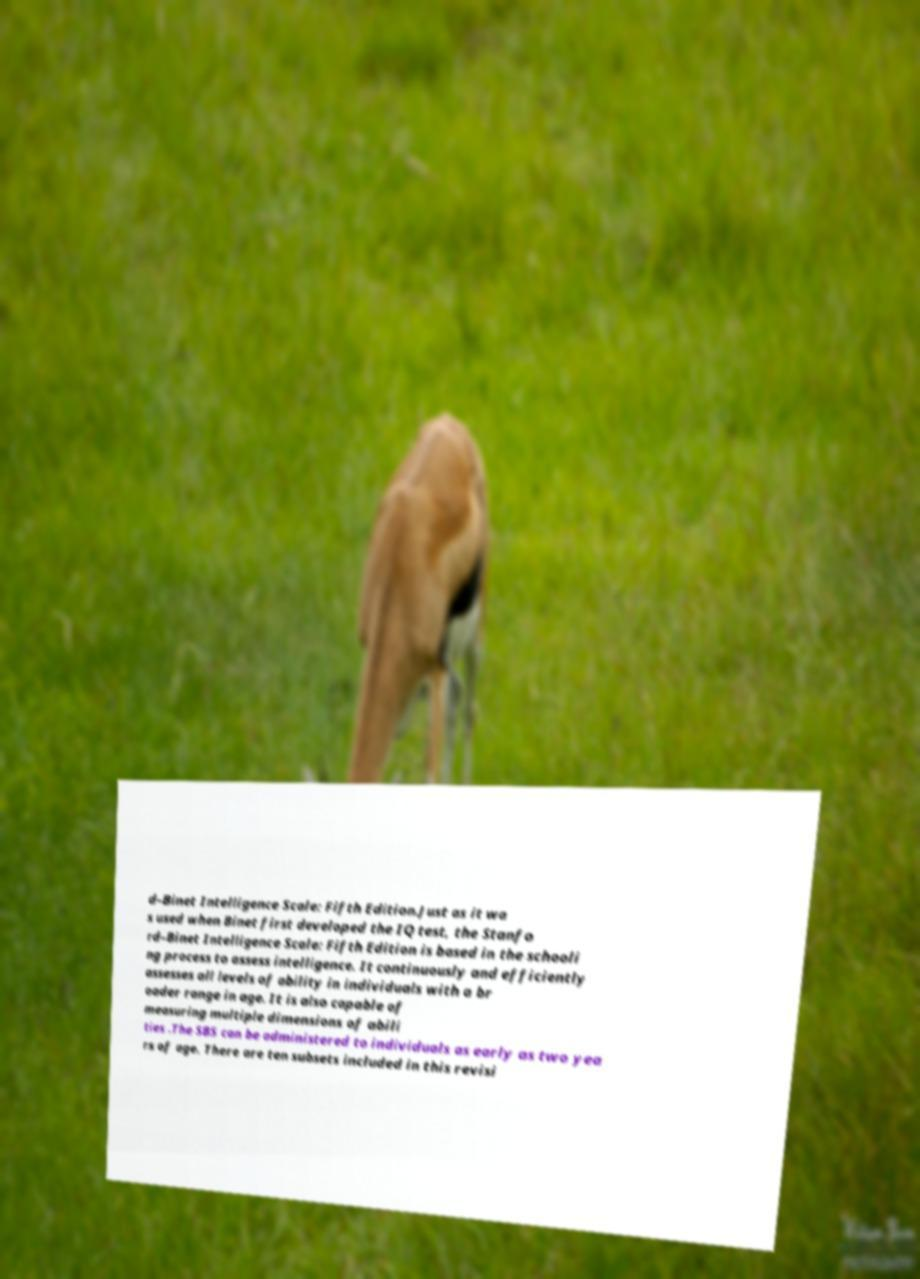Can you read and provide the text displayed in the image?This photo seems to have some interesting text. Can you extract and type it out for me? d–Binet Intelligence Scale: Fifth Edition.Just as it wa s used when Binet first developed the IQ test, the Stanfo rd–Binet Intelligence Scale: Fifth Edition is based in the schooli ng process to assess intelligence. It continuously and efficiently assesses all levels of ability in individuals with a br oader range in age. It is also capable of measuring multiple dimensions of abili ties .The SB5 can be administered to individuals as early as two yea rs of age. There are ten subsets included in this revisi 